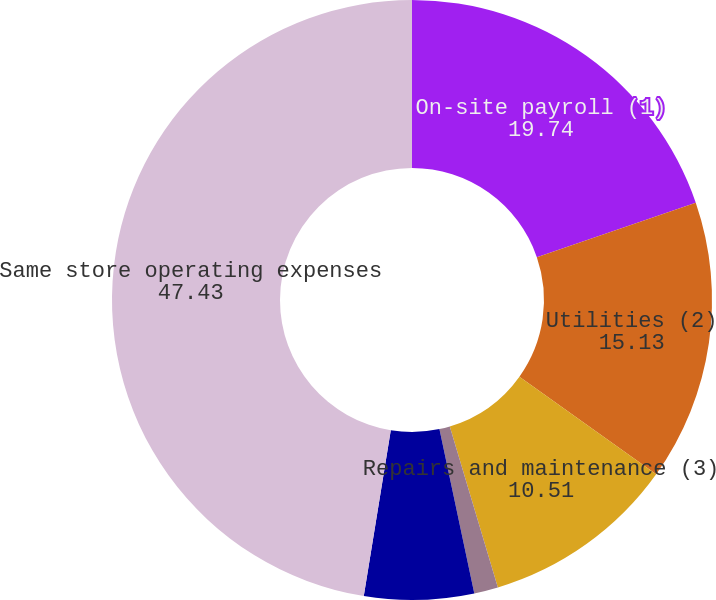Convert chart to OTSL. <chart><loc_0><loc_0><loc_500><loc_500><pie_chart><fcel>On-site payroll (1)<fcel>Utilities (2)<fcel>Repairs and maintenance (3)<fcel>Insurance Leasing and<fcel>Other on-site operating<fcel>Same store operating expenses<nl><fcel>19.74%<fcel>15.13%<fcel>10.51%<fcel>1.29%<fcel>5.9%<fcel>47.43%<nl></chart> 